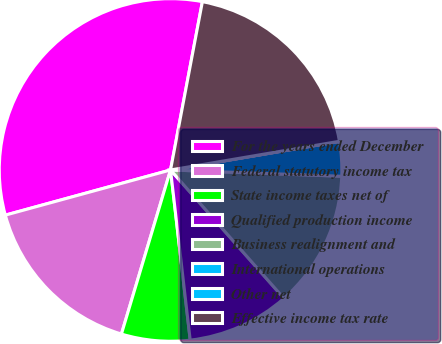Convert chart to OTSL. <chart><loc_0><loc_0><loc_500><loc_500><pie_chart><fcel>For the years ended December<fcel>Federal statutory income tax<fcel>State income taxes net of<fcel>Qualified production income<fcel>Business realignment and<fcel>International operations<fcel>Other net<fcel>Effective income tax rate<nl><fcel>32.22%<fcel>16.12%<fcel>6.46%<fcel>9.68%<fcel>12.9%<fcel>3.24%<fcel>0.02%<fcel>19.34%<nl></chart> 